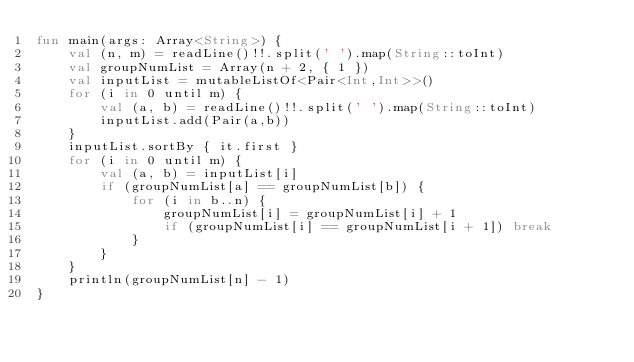Convert code to text. <code><loc_0><loc_0><loc_500><loc_500><_Kotlin_>fun main(args: Array<String>) {
    val (n, m) = readLine()!!.split(' ').map(String::toInt)
    val groupNumList = Array(n + 2, { 1 })
    val inputList = mutableListOf<Pair<Int,Int>>()
    for (i in 0 until m) {
        val (a, b) = readLine()!!.split(' ').map(String::toInt)
        inputList.add(Pair(a,b))
    }
    inputList.sortBy { it.first }
    for (i in 0 until m) {
        val (a, b) = inputList[i]
        if (groupNumList[a] == groupNumList[b]) {
            for (i in b..n) {
                groupNumList[i] = groupNumList[i] + 1
                if (groupNumList[i] == groupNumList[i + 1]) break
            }
        }
    }
    println(groupNumList[n] - 1)
}
</code> 